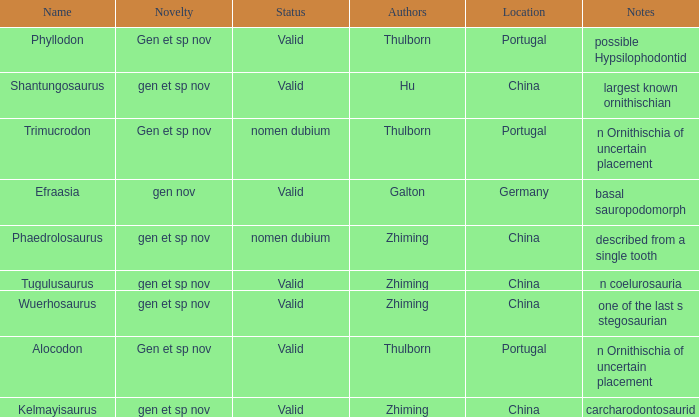What is the Novelty of the dinosaur that was named by the Author, Zhiming, and whose Notes are, "carcharodontosaurid"? Gen et sp nov. Can you give me this table as a dict? {'header': ['Name', 'Novelty', 'Status', 'Authors', 'Location', 'Notes'], 'rows': [['Phyllodon', 'Gen et sp nov', 'Valid', 'Thulborn', 'Portugal', 'possible Hypsilophodontid'], ['Shantungosaurus', 'gen et sp nov', 'Valid', 'Hu', 'China', 'largest known ornithischian'], ['Trimucrodon', 'Gen et sp nov', 'nomen dubium', 'Thulborn', 'Portugal', 'n Ornithischia of uncertain placement'], ['Efraasia', 'gen nov', 'Valid', 'Galton', 'Germany', 'basal sauropodomorph'], ['Phaedrolosaurus', 'gen et sp nov', 'nomen dubium', 'Zhiming', 'China', 'described from a single tooth'], ['Tugulusaurus', 'gen et sp nov', 'Valid', 'Zhiming', 'China', 'n coelurosauria'], ['Wuerhosaurus', 'gen et sp nov', 'Valid', 'Zhiming', 'China', 'one of the last s stegosaurian'], ['Alocodon', 'Gen et sp nov', 'Valid', 'Thulborn', 'Portugal', 'n Ornithischia of uncertain placement'], ['Kelmayisaurus', 'gen et sp nov', 'Valid', 'Zhiming', 'China', 'carcharodontosaurid']]} 